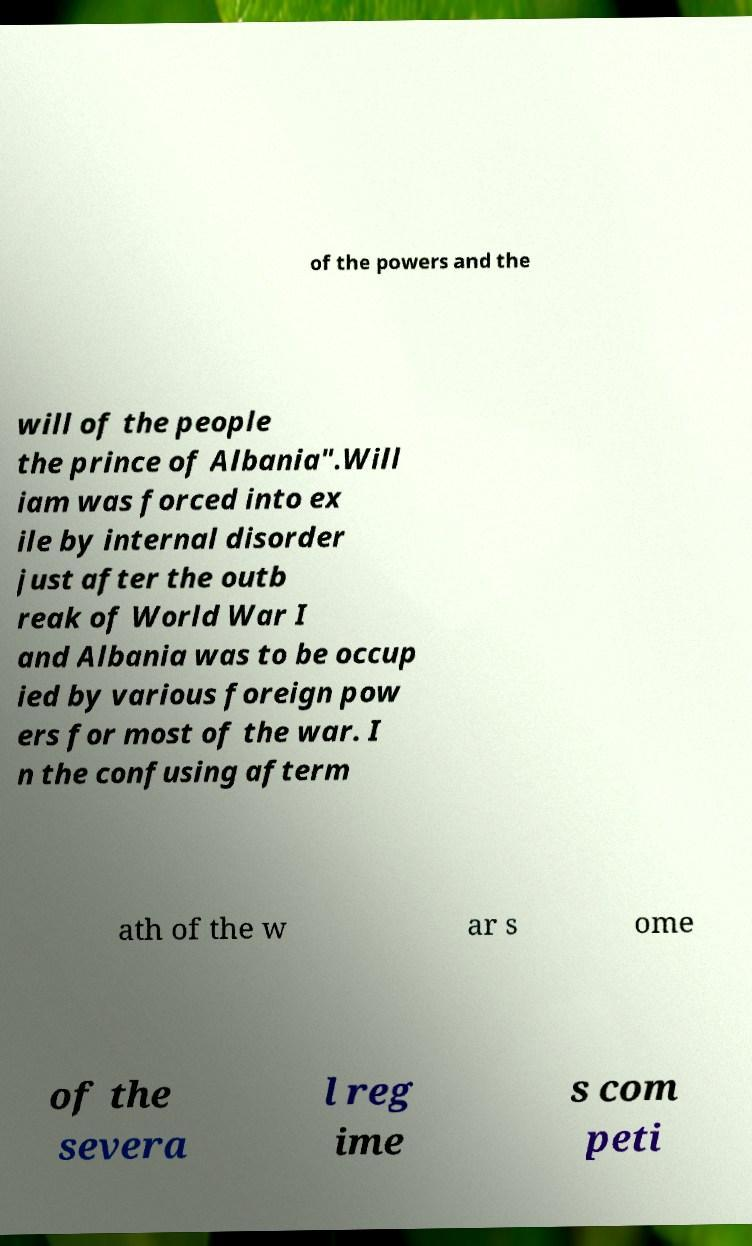Please identify and transcribe the text found in this image. of the powers and the will of the people the prince of Albania".Will iam was forced into ex ile by internal disorder just after the outb reak of World War I and Albania was to be occup ied by various foreign pow ers for most of the war. I n the confusing afterm ath of the w ar s ome of the severa l reg ime s com peti 